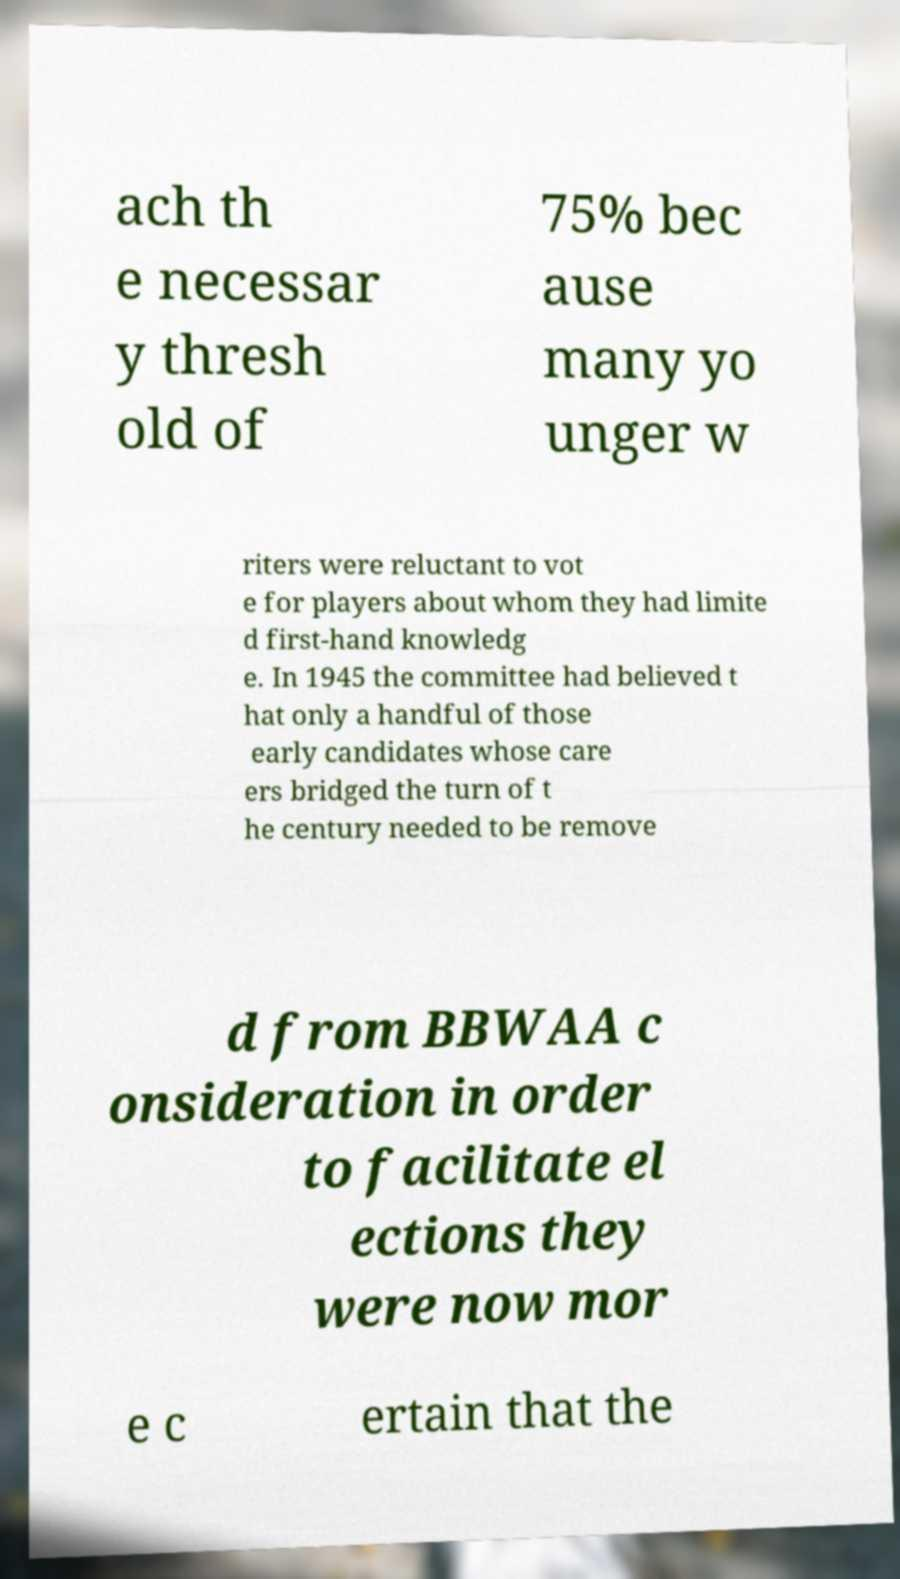Could you extract and type out the text from this image? ach th e necessar y thresh old of 75% bec ause many yo unger w riters were reluctant to vot e for players about whom they had limite d first-hand knowledg e. In 1945 the committee had believed t hat only a handful of those early candidates whose care ers bridged the turn of t he century needed to be remove d from BBWAA c onsideration in order to facilitate el ections they were now mor e c ertain that the 